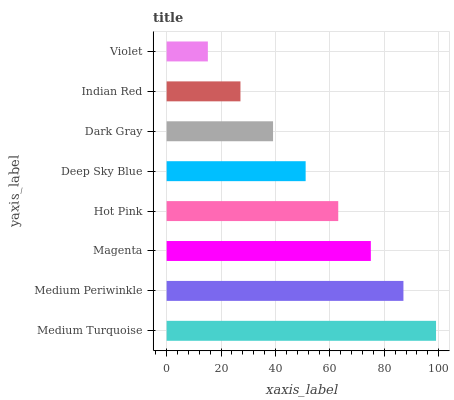Is Violet the minimum?
Answer yes or no. Yes. Is Medium Turquoise the maximum?
Answer yes or no. Yes. Is Medium Periwinkle the minimum?
Answer yes or no. No. Is Medium Periwinkle the maximum?
Answer yes or no. No. Is Medium Turquoise greater than Medium Periwinkle?
Answer yes or no. Yes. Is Medium Periwinkle less than Medium Turquoise?
Answer yes or no. Yes. Is Medium Periwinkle greater than Medium Turquoise?
Answer yes or no. No. Is Medium Turquoise less than Medium Periwinkle?
Answer yes or no. No. Is Hot Pink the high median?
Answer yes or no. Yes. Is Deep Sky Blue the low median?
Answer yes or no. Yes. Is Deep Sky Blue the high median?
Answer yes or no. No. Is Medium Turquoise the low median?
Answer yes or no. No. 